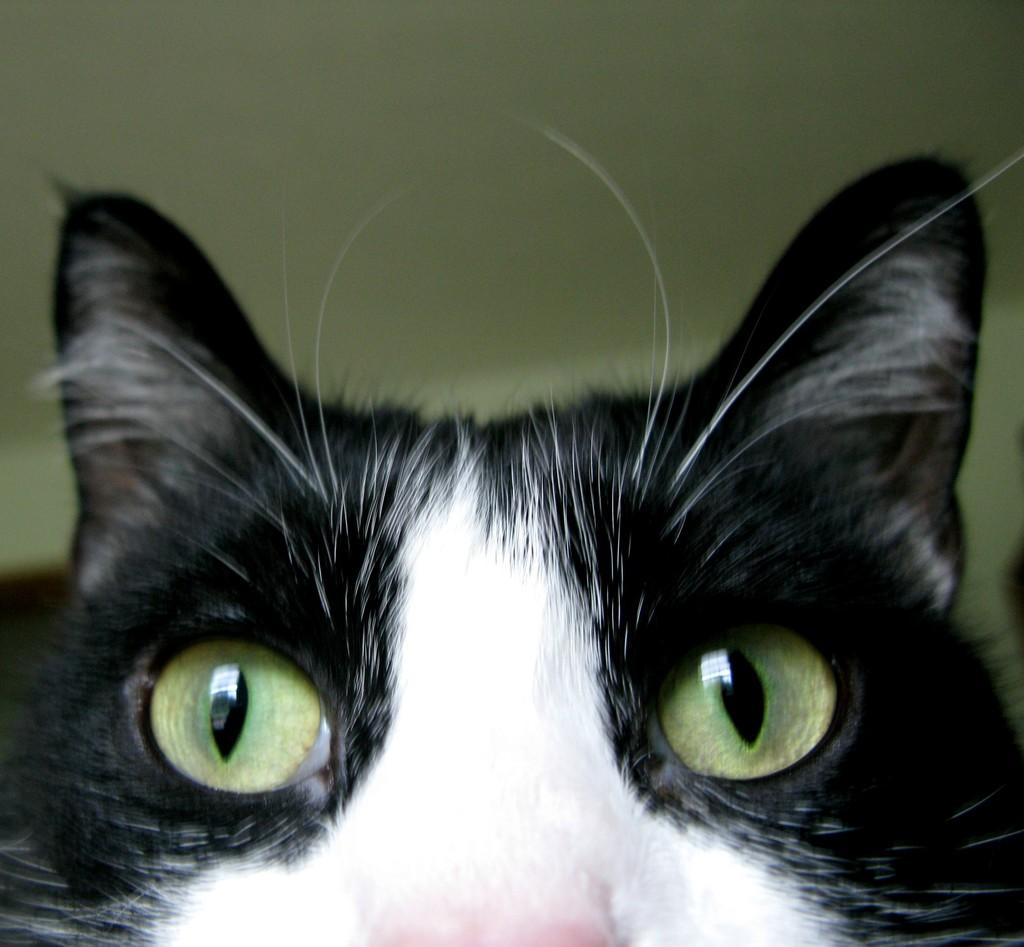What animal is in the foreground of the image? There is a cat in the foreground of the image. What can be seen in the background of the image? There is a wall in the background of the image. How many fowl are perched on the wall in the image? There are no fowl present in the image; it only features a cat in the foreground and a wall in the background. 